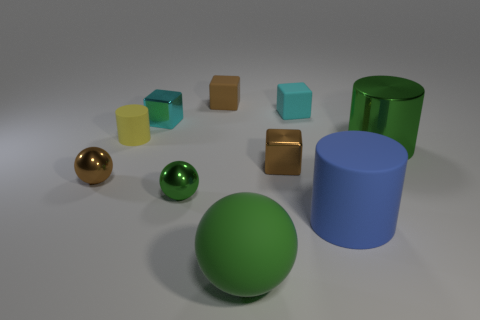How many things are either tiny cyan cubes or tiny brown objects that are in front of the tiny cyan matte block?
Your answer should be compact. 4. What number of other things are there of the same color as the large matte cylinder?
Keep it short and to the point. 0. What number of yellow objects are either tiny rubber things or shiny spheres?
Your answer should be compact. 1. There is a shiny object to the right of the small brown thing that is to the right of the large green rubber thing; are there any yellow cylinders on the left side of it?
Ensure brevity in your answer.  Yes. Is the color of the big shiny thing the same as the big rubber cylinder?
Keep it short and to the point. No. What color is the tiny rubber thing that is on the right side of the brown block right of the green rubber object?
Keep it short and to the point. Cyan. What number of big objects are brown shiny balls or green metallic cylinders?
Your answer should be very brief. 1. What color is the rubber thing that is both to the left of the small cyan rubber object and behind the cyan metallic cube?
Ensure brevity in your answer.  Brown. Does the blue cylinder have the same material as the small yellow object?
Offer a very short reply. Yes. What is the shape of the big metallic object?
Keep it short and to the point. Cylinder. 